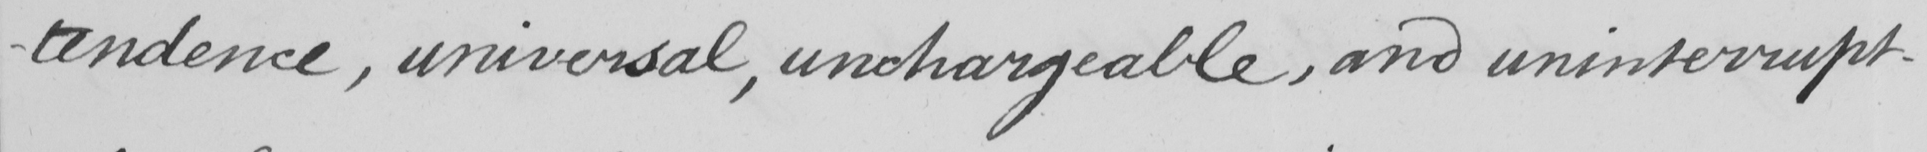What does this handwritten line say? -tendence , universal , unchargeable , and uninterrupt- 